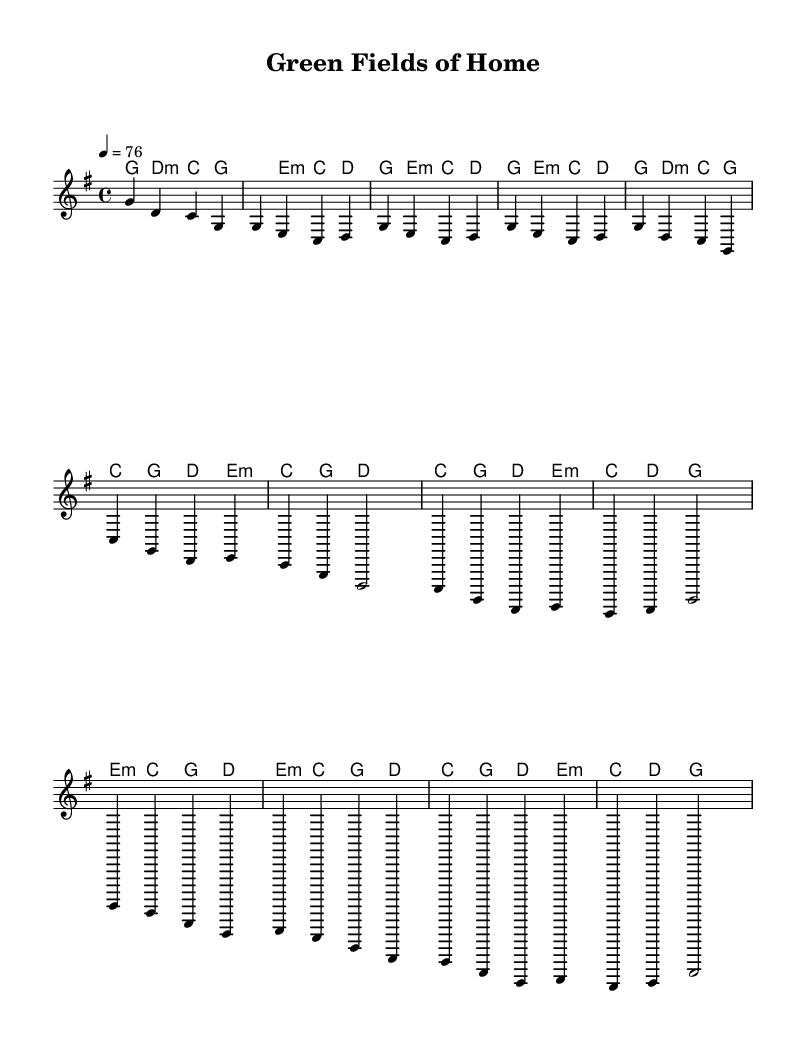What is the key signature of this music? The key signature is G major, which has one sharp (F#). This is determined by the presence of the sharp sign associated with the F note in the key signature section.
Answer: G major What is the time signature of this piece? The time signature is 4/4, which is indicated at the beginning of the sheet music. This means there are four beats per measure, and the quarter note gets one beat.
Answer: 4/4 What is the tempo marking for this piece? The tempo marking is a quarter note equals 76 BPM. This indicates the speed at which the piece should be played, found at the beginning of the score.
Answer: 76 How many measures are in the chorus section? The chorus section consists of four measures. This can be counted by looking at the grouping of notes and measures in the provided melody and harmonies.
Answer: 4 What type of song structure is predominantly used in "Green Fields of Home"? The song follows a typical verse-chorus structure, which can be identified by the repeating sections labeled for verses and choruses.
Answer: Verse-chorus What is the primary theme of the lyrics, as suggested by the title "Green Fields of Home"? The primary theme revolves around the celebration of small-town green initiatives. This is inferred from the title and the context of the music style.
Answer: Sustainability What kind of harmony is mainly used throughout the piece? The piece predominantly uses triadic harmonies, which are chords built by stacking notes in thirds. This can be observed from the chord structure in the harmonies section.
Answer: Triadic harmonies 